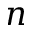Convert formula to latex. <formula><loc_0><loc_0><loc_500><loc_500>n</formula> 